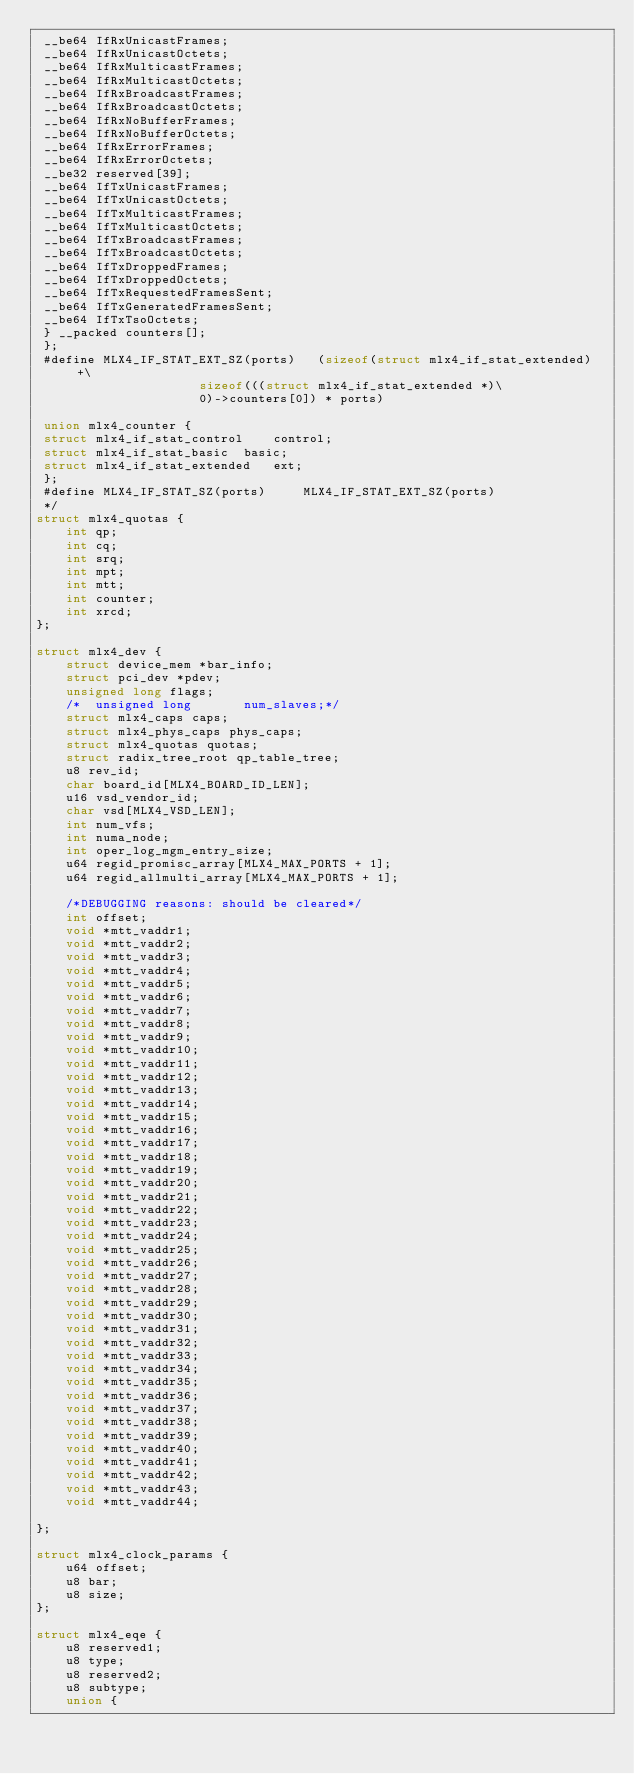<code> <loc_0><loc_0><loc_500><loc_500><_C_> __be64 IfRxUnicastFrames;
 __be64 IfRxUnicastOctets;
 __be64 IfRxMulticastFrames;
 __be64 IfRxMulticastOctets;
 __be64 IfRxBroadcastFrames;
 __be64 IfRxBroadcastOctets;
 __be64 IfRxNoBufferFrames;
 __be64 IfRxNoBufferOctets;
 __be64 IfRxErrorFrames;
 __be64 IfRxErrorOctets;
 __be32 reserved[39];
 __be64 IfTxUnicastFrames;
 __be64 IfTxUnicastOctets;
 __be64 IfTxMulticastFrames;
 __be64 IfTxMulticastOctets;
 __be64 IfTxBroadcastFrames;
 __be64 IfTxBroadcastOctets;
 __be64 IfTxDroppedFrames;
 __be64 IfTxDroppedOctets;
 __be64 IfTxRequestedFramesSent;
 __be64 IfTxGeneratedFramesSent;
 __be64 IfTxTsoOctets;
 } __packed counters[];
 };
 #define MLX4_IF_STAT_EXT_SZ(ports)   (sizeof(struct mlx4_if_stat_extended) +\
				      sizeof(((struct mlx4_if_stat_extended *)\
				      0)->counters[0]) * ports)

 union mlx4_counter {
 struct mlx4_if_stat_control	control;
 struct mlx4_if_stat_basic	basic;
 struct mlx4_if_stat_extended	ext;
 };
 #define MLX4_IF_STAT_SZ(ports)		MLX4_IF_STAT_EXT_SZ(ports)
 */
struct mlx4_quotas {
	int qp;
	int cq;
	int srq;
	int mpt;
	int mtt;
	int counter;
	int xrcd;
};

struct mlx4_dev {
	struct device_mem *bar_info;
	struct pci_dev *pdev;
	unsigned long flags;
	/*	unsigned long		num_slaves;*/
	struct mlx4_caps caps;
	struct mlx4_phys_caps phys_caps;
	struct mlx4_quotas quotas;
	struct radix_tree_root qp_table_tree;
	u8 rev_id;
	char board_id[MLX4_BOARD_ID_LEN];
	u16 vsd_vendor_id;
	char vsd[MLX4_VSD_LEN];
	int num_vfs;
	int numa_node;
	int oper_log_mgm_entry_size;
	u64 regid_promisc_array[MLX4_MAX_PORTS + 1];
	u64 regid_allmulti_array[MLX4_MAX_PORTS + 1];

	/*DEBUGGING reasons: should be cleared*/
	int offset;
	void *mtt_vaddr1;
	void *mtt_vaddr2;
	void *mtt_vaddr3;
	void *mtt_vaddr4;
	void *mtt_vaddr5;
	void *mtt_vaddr6;
	void *mtt_vaddr7;
	void *mtt_vaddr8;
	void *mtt_vaddr9;
	void *mtt_vaddr10;
	void *mtt_vaddr11;
	void *mtt_vaddr12;
	void *mtt_vaddr13;
	void *mtt_vaddr14;
	void *mtt_vaddr15;
	void *mtt_vaddr16;
	void *mtt_vaddr17;
	void *mtt_vaddr18;
	void *mtt_vaddr19;
	void *mtt_vaddr20;
	void *mtt_vaddr21;
	void *mtt_vaddr22;
	void *mtt_vaddr23;
	void *mtt_vaddr24;
	void *mtt_vaddr25;
	void *mtt_vaddr26;
	void *mtt_vaddr27;
	void *mtt_vaddr28;
	void *mtt_vaddr29;
	void *mtt_vaddr30;
	void *mtt_vaddr31;
	void *mtt_vaddr32;
	void *mtt_vaddr33;
	void *mtt_vaddr34;
	void *mtt_vaddr35;
	void *mtt_vaddr36;
	void *mtt_vaddr37;
	void *mtt_vaddr38;
	void *mtt_vaddr39;
	void *mtt_vaddr40;
	void *mtt_vaddr41;
	void *mtt_vaddr42;
	void *mtt_vaddr43;
	void *mtt_vaddr44;

};

struct mlx4_clock_params {
	u64 offset;
	u8 bar;
	u8 size;
};

struct mlx4_eqe {
	u8 reserved1;
	u8 type;
	u8 reserved2;
	u8 subtype;
	union {</code> 